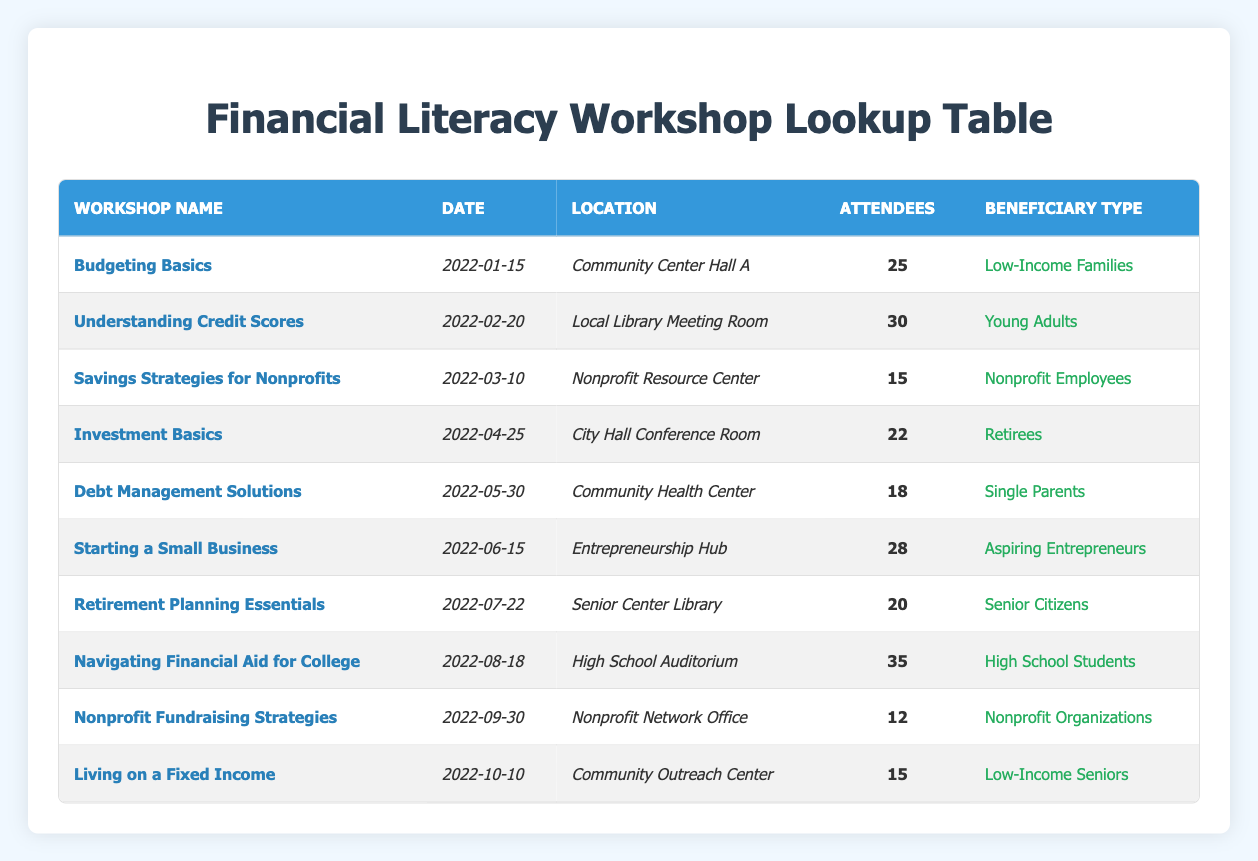What was the most attended workshop in 2022? The table shows the number of attendees per workshop. By examining the "Attendees" column, the workshop "Navigating Financial Aid for College" has the highest attendance of 35.
Answer: Navigating Financial Aid for College How many attendees participated in workshops for Senior Citizens? From the table, there is one workshop listed for Senior Citizens called "Retirement Planning Essentials," which had 20 attendees. Therefore, the total number of attendees is just that single workshop's attendance.
Answer: 20 What is the total number of attendees across all workshops? To find the total number of attendees, we add the number of attendees from each workshop: 25 + 30 + 15 + 22 + 18 + 28 + 20 + 35 + 12 + 15 = 315. Thus, the total attendance across all workshops is 315.
Answer: 315 Did the workshop "Savings Strategies for Nonprofits" have more attendees than "Investment Basics"? "Savings Strategies for Nonprofits" had 15 attendees and "Investment Basics" had 22 attendees. Since 15 is less than 22, "Savings Strategies for Nonprofits" did not have more attendees.
Answer: No What is the average number of attendees for workshops focused on families and single parents? There are two workshops relevant to this group: "Budgeting Basics" (25 attendees) and "Debt Management Solutions" (18 attendees). The total number of attendees is 25 + 18 = 43. The average is calculated by dividing 43 by 2 (the number of workshops), which equals 21.5.
Answer: 21.5 Which workshop had the fewest attendees, and how many attended? Examining the "Attendees" column, the workshop "Nonprofit Fundraising Strategies" has the lowest attendance of 12.
Answer: Nonprofit Fundraising Strategies, 12 What types of beneficiaries attended workshops on personal finance topics in 2022? The table shows a variety of beneficiary types, including Low-Income Families, Young Adults, Nonprofit Employees, Retirees, Single Parents, Aspiring Entrepreneurs, Senior Citizens, High School Students, Nonprofit Organizations, and Low-Income Seniors.
Answer: Various types: Low-Income Families, Young Adults, Nonprofit Employees, etc How many workshops were held in the location "Community Center"? The "Community Center" hosted two workshops: "Budgeting Basics" and "Living on a Fixed Income." Therefore, the total is 2.
Answer: 2 